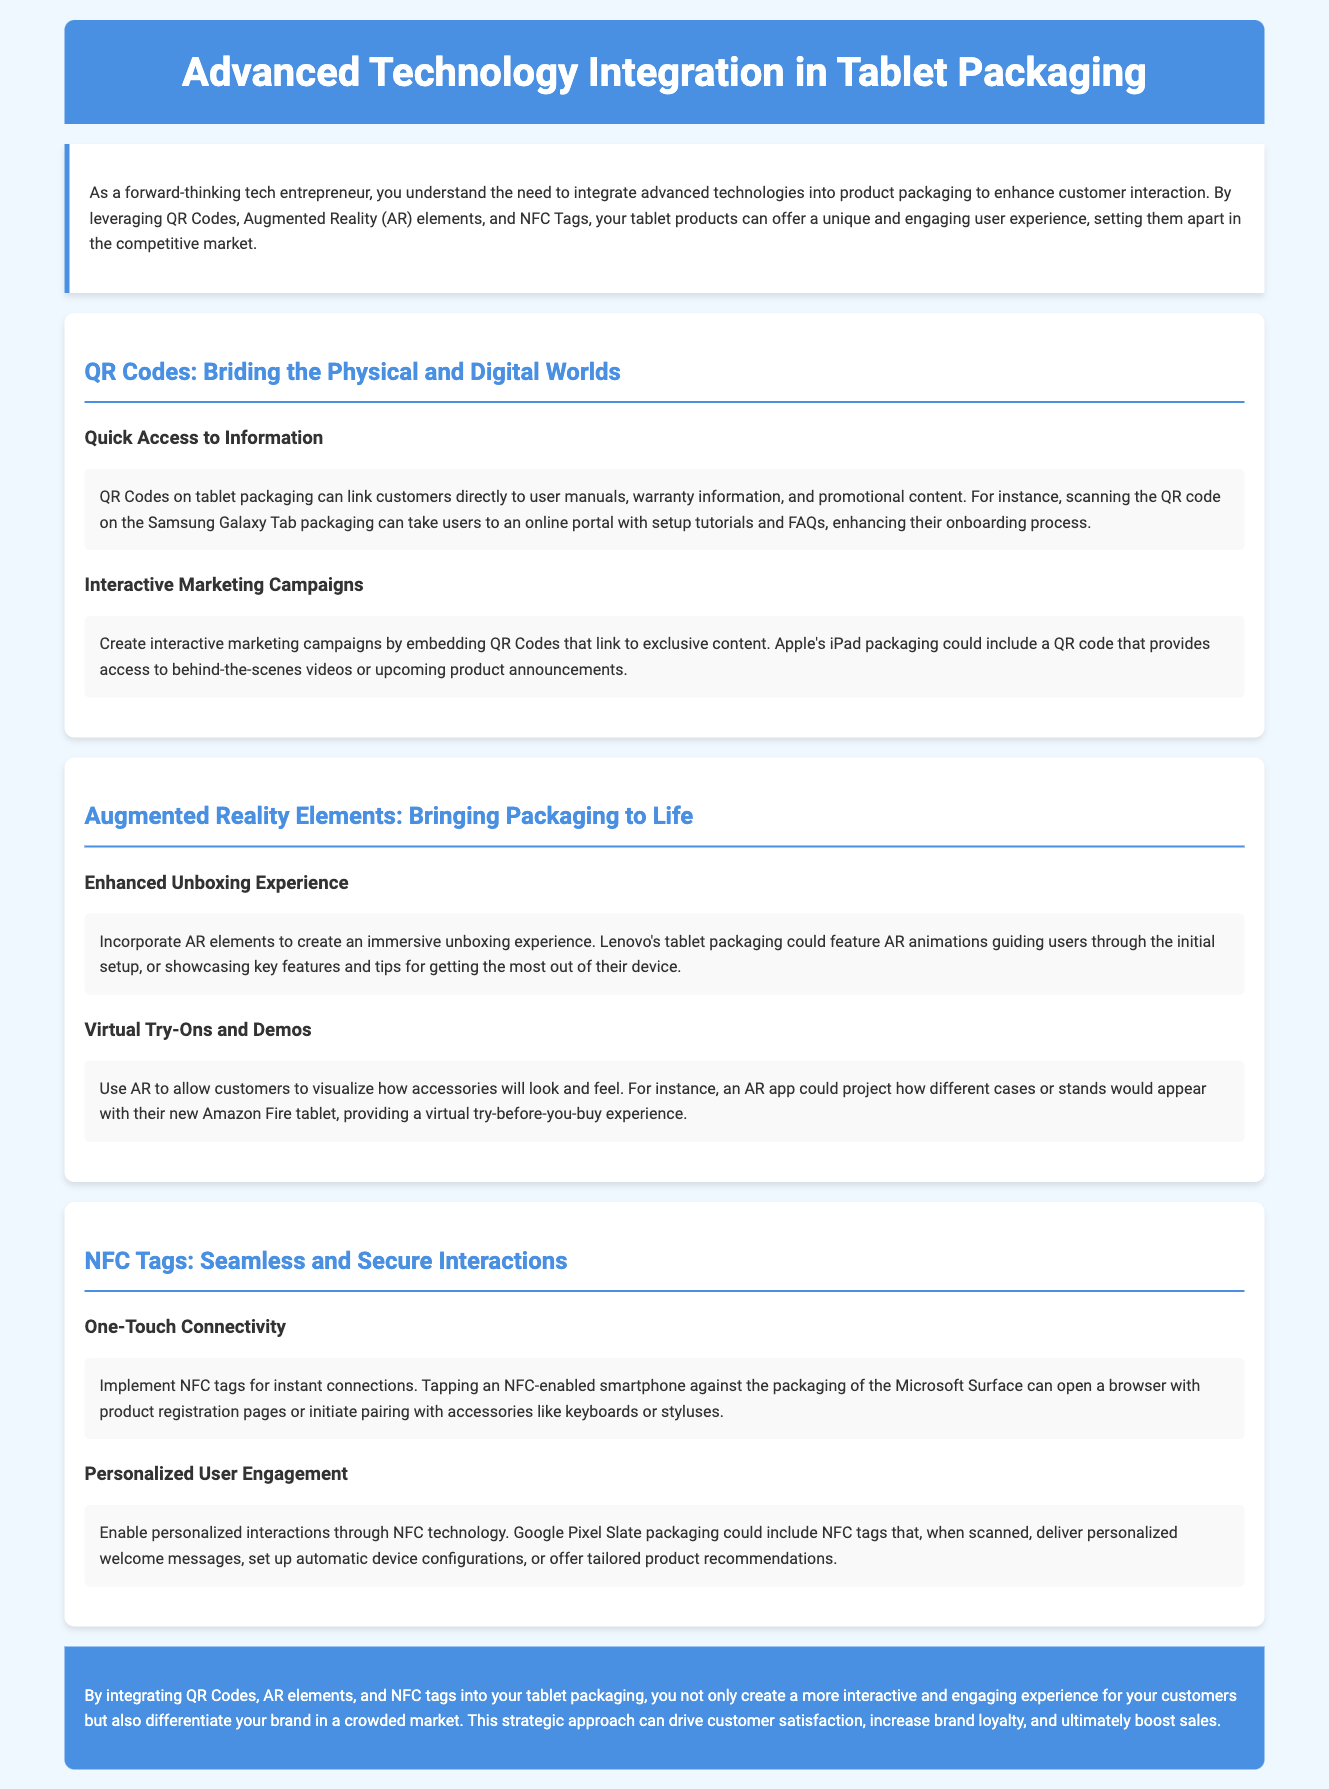What technology links customers to information on tablet packaging? The document mentions that QR Codes on tablet packaging can link customers directly to user manuals, warranty information, and promotional content.
Answer: QR Codes What immersive experience can AR elements provide during unboxing? The document states that incorporating AR elements can create an immersive unboxing experience that guides users through the initial setup.
Answer: Enhanced Unboxing Experience Which company's tablet packaging uses NFC tags for instant connections? The document specifically mentions that Microsoft Surface packaging can use NFC tags for instant connections to open a browser for product registration pages.
Answer: Microsoft Surface What type of marketing campaigns can QR Codes create? The document indicates that QR Codes can create interactive marketing campaigns by linking to exclusive content.
Answer: Interactive Marketing Campaigns What feature does the AR app allow for customers? The document describes that an AR app can project how different accessories will look and feel with their new device, providing a virtual try-before-you-buy experience.
Answer: Virtual Try-Ons and Demos What strategic approach can drive customer satisfaction? The document concludes that integrating QR Codes, AR elements, and NFC tags into tablet packaging is a strategic approach to enhance customer experience.
Answer: Integrating QR Codes, AR elements, and NFC tags What does NFC technology enable for users? The document highlights that NFC technology can enable personalized interactions through welcome messages and automatic configurations.
Answer: Personalized User Engagement What is the overall benefit stated for integrating advanced technologies? The document suggests that integrating these technologies differentiates the brand in a crowded market and boosts sales.
Answer: Boost sales 